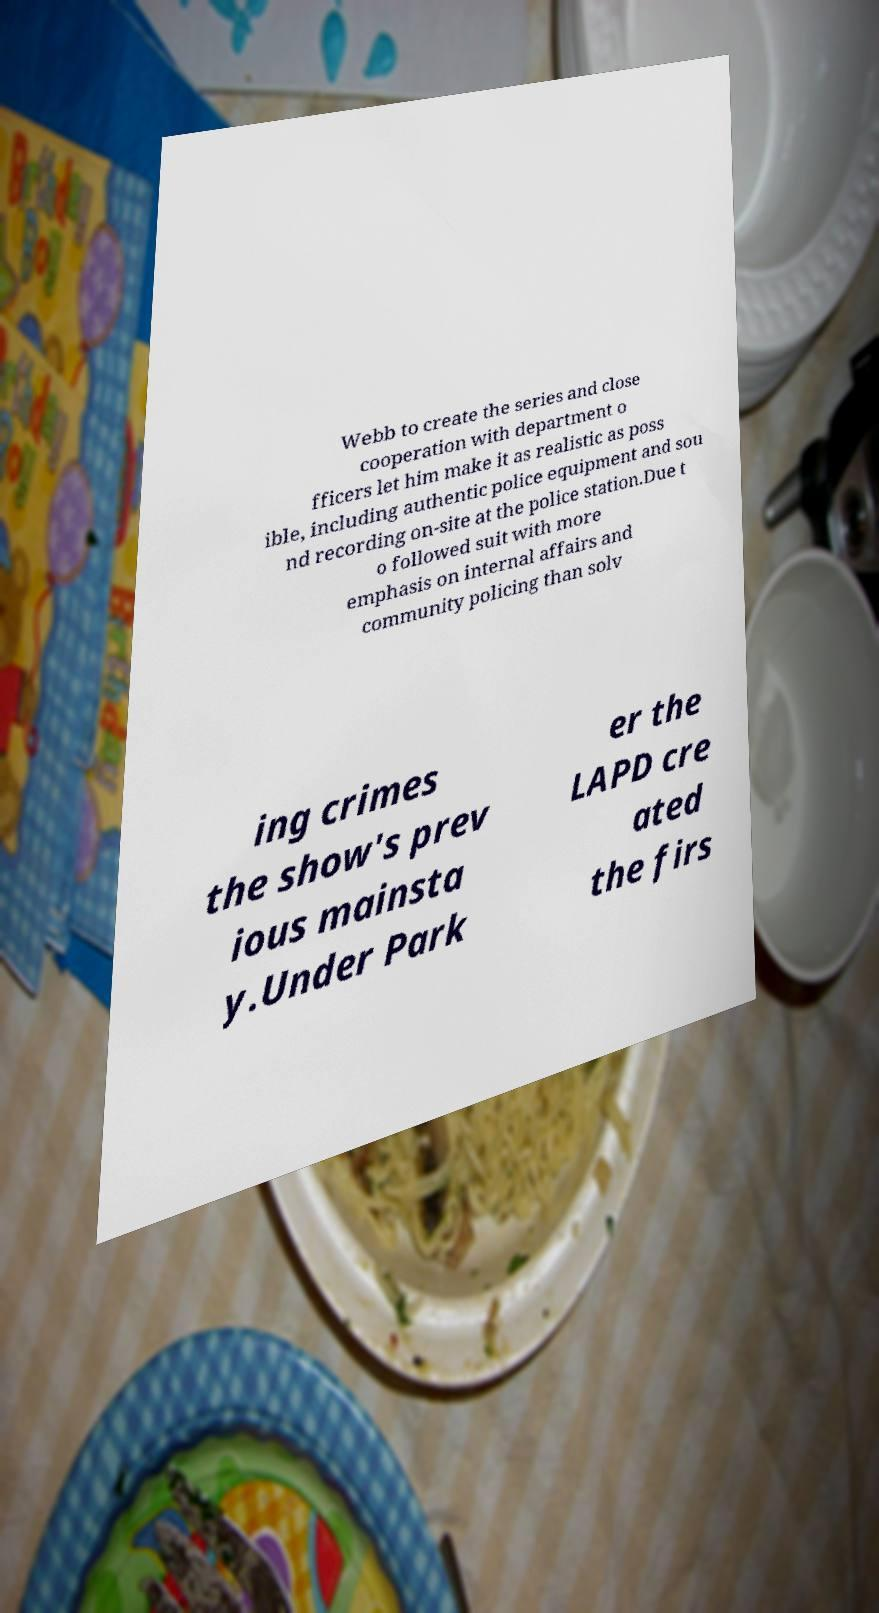Please read and relay the text visible in this image. What does it say? Webb to create the series and close cooperation with department o fficers let him make it as realistic as poss ible, including authentic police equipment and sou nd recording on-site at the police station.Due t o followed suit with more emphasis on internal affairs and community policing than solv ing crimes the show's prev ious mainsta y.Under Park er the LAPD cre ated the firs 